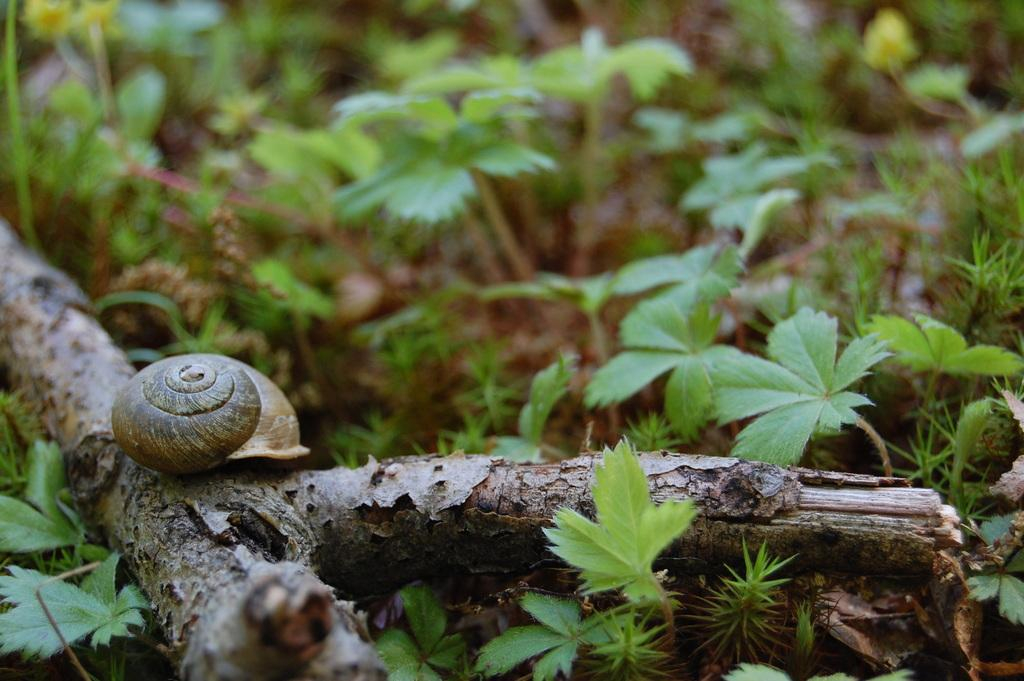What type of living organisms are present in the image? There are tiny plants in the image. Can you describe the other living organism in the image? There is a snail on a branch in the image. How many bells are hanging from the tree in the image? There is no tree or bells present in the image; it features tiny plants and a snail on a branch. 